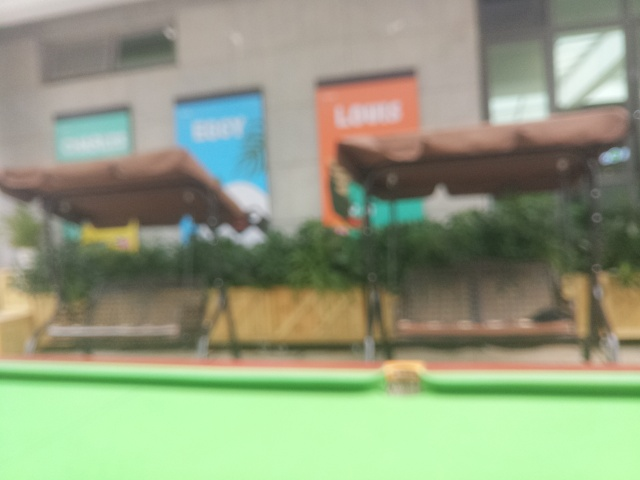Is the loss of texture details severe? Yes, the severe loss of texture details is evident. The image is blurry, making it difficult to discern any specific details or features clearly. Enhancing the sharpness might reveal more information, but as it stands, the clarity is significantly compromised. 